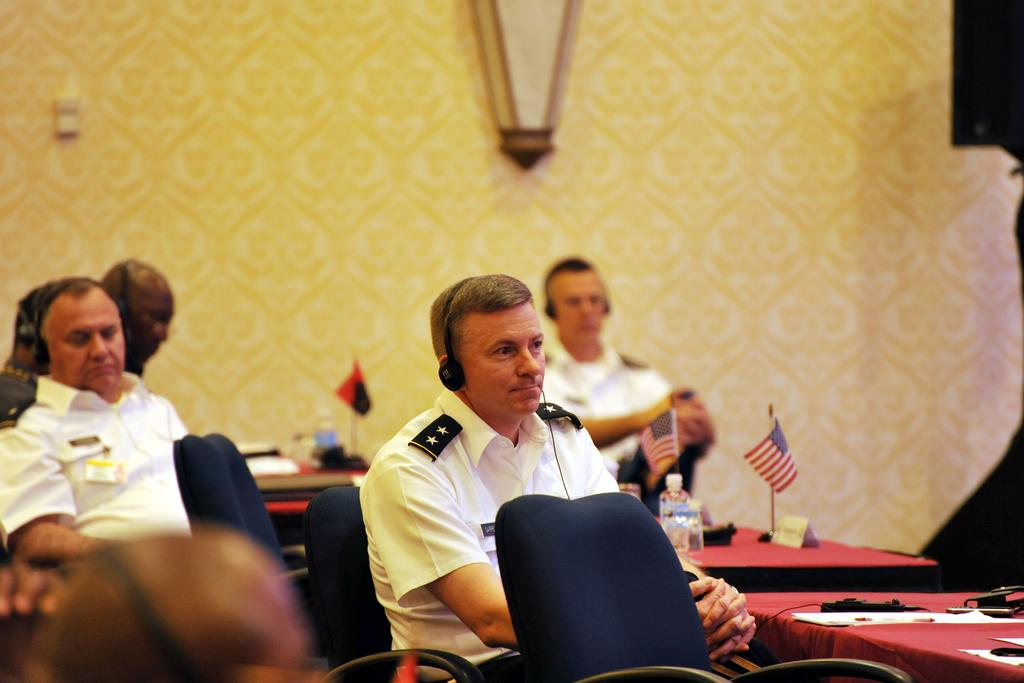How many people are in the image? There are six persons in the image. What are the persons doing in the image? The persons are sitting on chairs. What objects are in front of the chairs? There are tables in front of the chairs. What can be seen on the tables? Flags and a bottle are present on the tables. What is visible in the background of the image? There is a wall in the background of the image. What type of governor is depicted on the table in the image? There is no governor depicted on the table in the image; only flags and a bottle are present. Can you tell me how many times the persons in the image smashed the basin? There is no basin present in the image, so it is not possible to determine if it was smashed or how many times. 